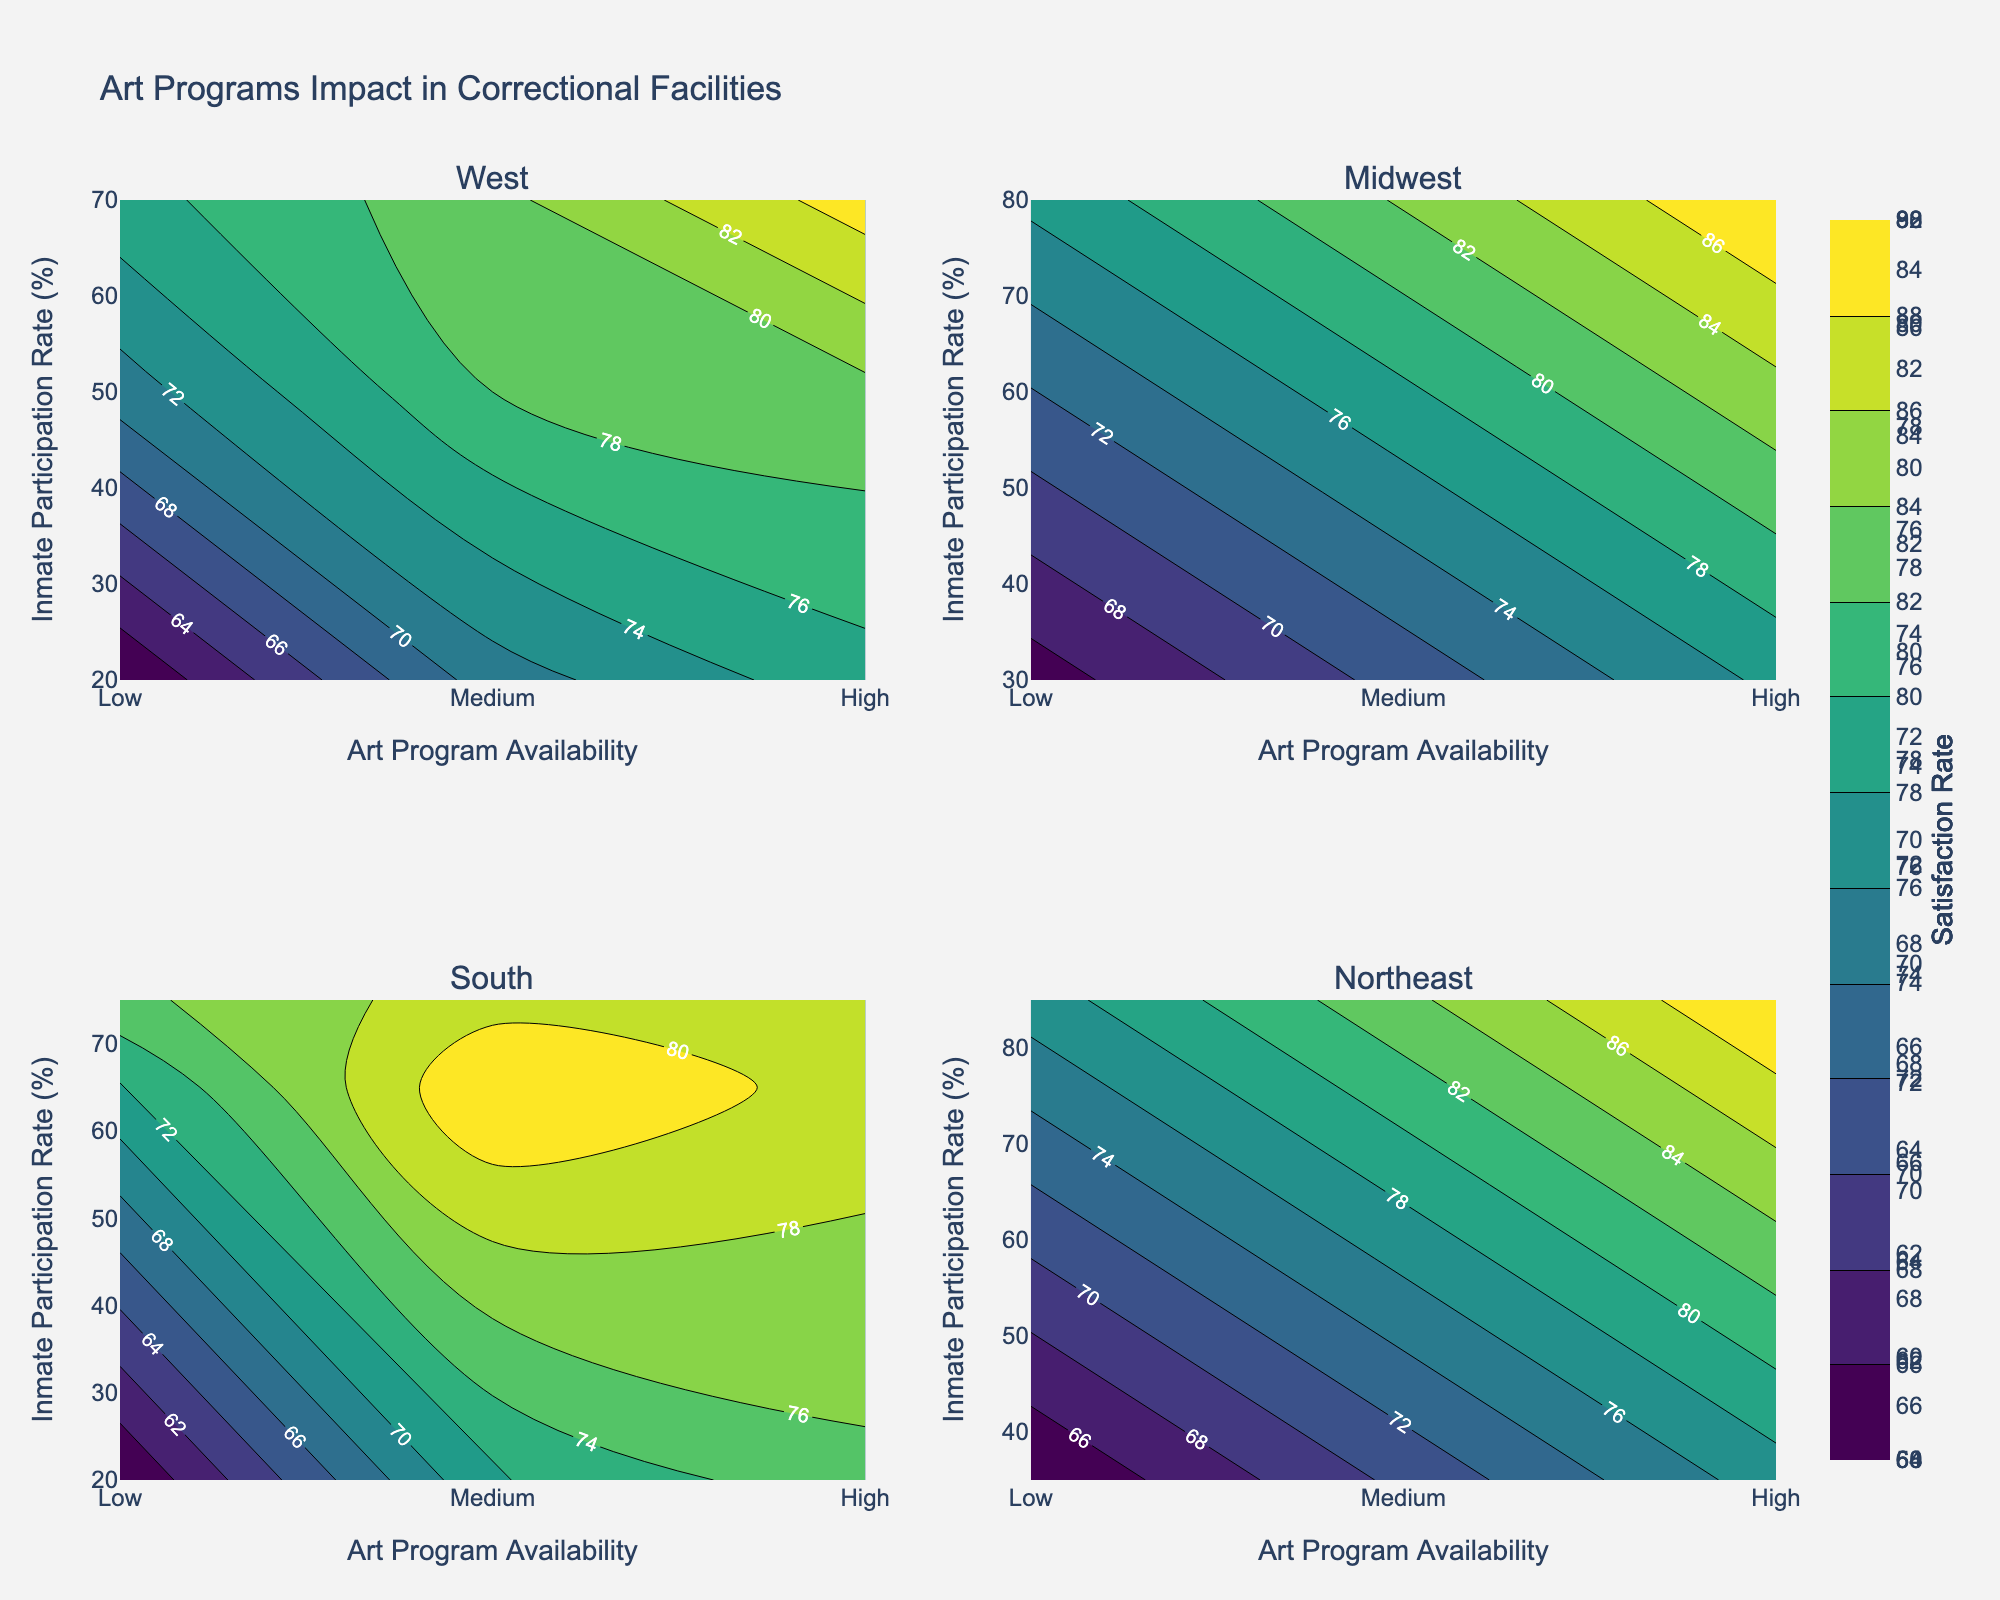What is the title of the figure? The title of the figure is stated at the top of the plot.
Answer: Art Programs Impact in Correctional Facilities How many regions are included in the subplots? The subplots are titled by geographic region, and there are four titles indicating four regions.
Answer: Four Which region has the highest inmate participation rate? By examining the subplots, the Northeast region has the highest participation rate of 85%.
Answer: Northeast What is the inmate satisfaction rate for 'High' art program availability in the West region? By looking at the West subplot, for a 'High' art program availability (3 on the x-axis), the satisfaction rate z is shown as 85%.
Answer: 85% How does inmate satisfaction in the Midwest compare between 'Low' and 'High' art program availability? In the Midwest subplot, 'Low' availability (1 on the x-axis) has a satisfaction rate of 65%, while 'High' availability (3 on the x-axis) has a satisfaction rate of 88%.
Answer: 'High' availability has a higher satisfaction rate than 'Low' availability Which facility in the South region shows the highest satisfaction rate, and what is the corresponding inmate participation rate? In the South subplot, the highest satisfaction rate is observed in Louisiana (85%), with a corresponding participation rate of 75%.
Answer: Louisiana, 75% Which region has the widest range of inmate participation rates? By comparing the y-axes across subplots, the South region has a wide range from 20% to 75%.
Answer: South In the Northeast region, what is the inmate satisfaction rate for 'Low' art program availability? In the subplot for the Northeast, for 'Low' availability (1 on the x-axis), the satisfaction rate is 64%.
Answer: 64% Which geographic region has the highest satisfaction rate for 'High' art program availability? Examining the subplots, the Northeast region shows the highest satisfaction rate of 90% for 'High' art program availability.
Answer: Northeast What is the difference in satisfaction rates between 'Medium' and 'Low' art program availability in the West region? In the West subplot, 'Medium' availability has a satisfaction rate of 78%, and 'Low' availability has a satisfaction rate of 60%; the difference is 78% - 60% = 18%.
Answer: 18% 